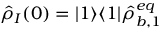<formula> <loc_0><loc_0><loc_500><loc_500>\hat { \rho } _ { I } ( 0 ) = | 1 \rangle \langle 1 | \hat { \rho } _ { b , 1 } ^ { e q }</formula> 